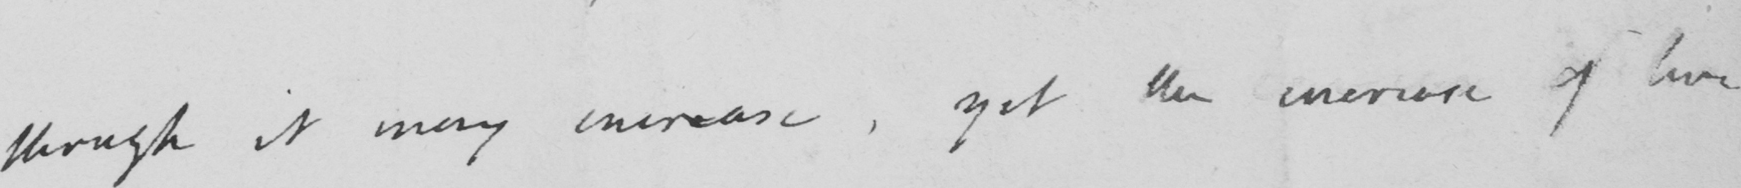Please provide the text content of this handwritten line. though it may increase, yet the increase of live 